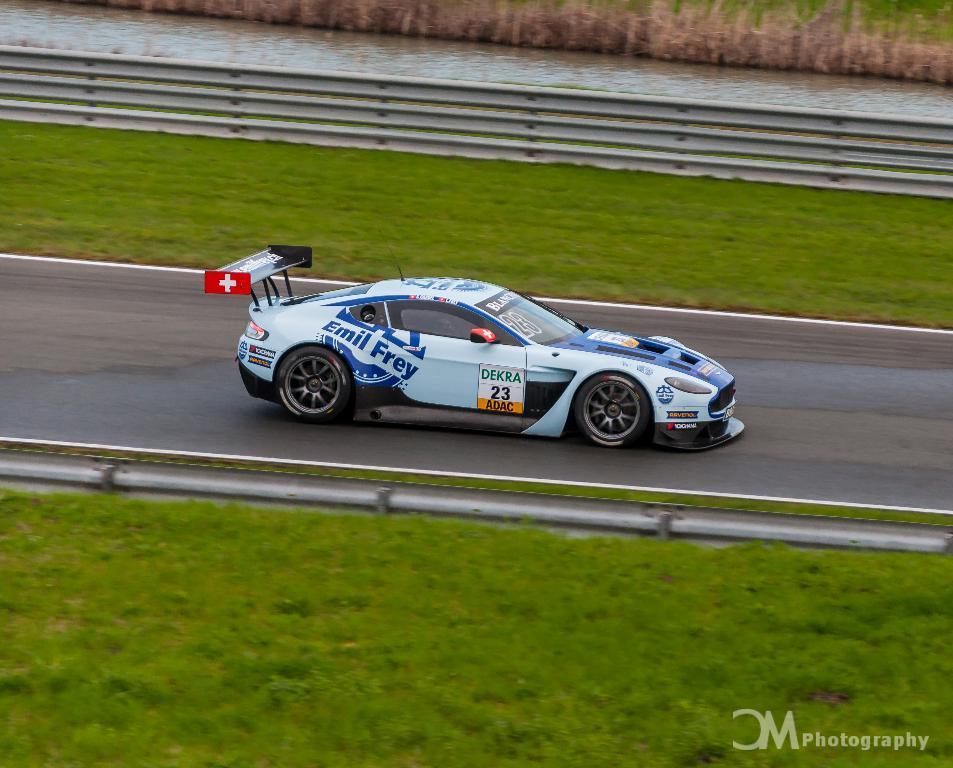Could you give a brief overview of what you see in this image? In this image in the center there is one car, at the bottom there is grass and road and in the background there is one river, railing and some grass. 